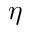Convert formula to latex. <formula><loc_0><loc_0><loc_500><loc_500>\eta</formula> 